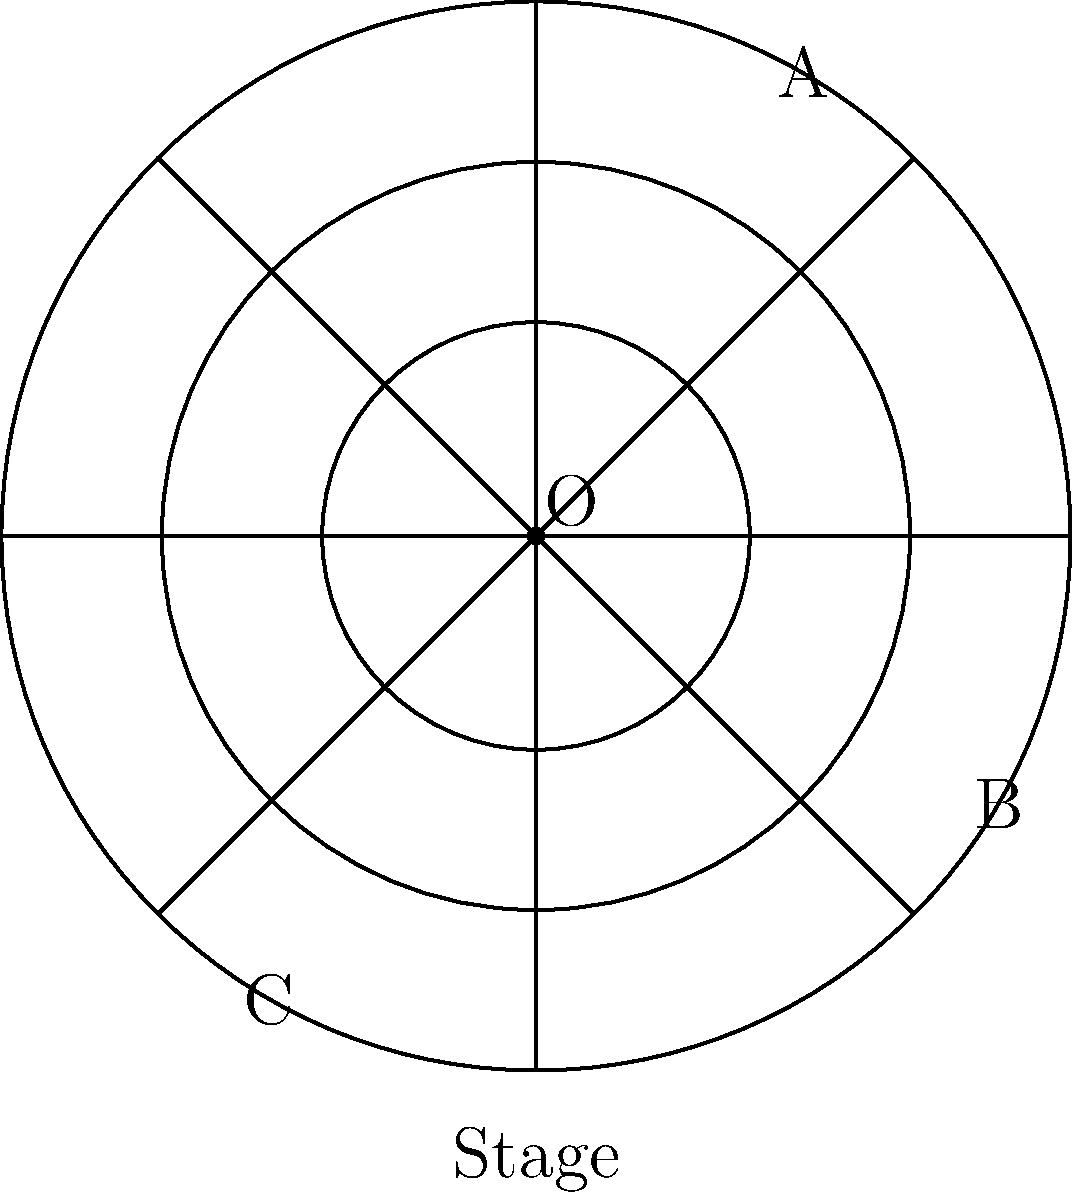As a prominent figure in Saratoga Springs' art community, you're tasked with describing the seating arrangement at SPAC using polar coordinates. Given the diagram of SPAC's amphitheater, where the stage is at the bottom and sections are divided radially, in which section would a seat at coordinates $(r, \theta) = (2.5, 225°)$ be located? To determine the section of the seat, we need to follow these steps:

1. Understand the polar coordinate system:
   - $r$ represents the distance from the origin (center)
   - $\theta$ represents the angle from the positive x-axis (counterclockwise)

2. Identify the given coordinates:
   - $r = 2.5$ (between the middle and outer circles)
   - $\theta = 225°$

3. Visualize the angle:
   - 225° is equivalent to 180° + 45°
   - This places the angle in the lower-left quadrant

4. Locate the point:
   - Move 2.5 units from the center
   - In the direction of 225°

5. Identify the section:
   - The diagram shows three main sections: A, B, and C
   - 225° falls within the octant that corresponds to section C

Therefore, a seat at $(r, \theta) = (2.5, 225°)$ would be located in section C of SPAC's amphitheater.
Answer: Section C 